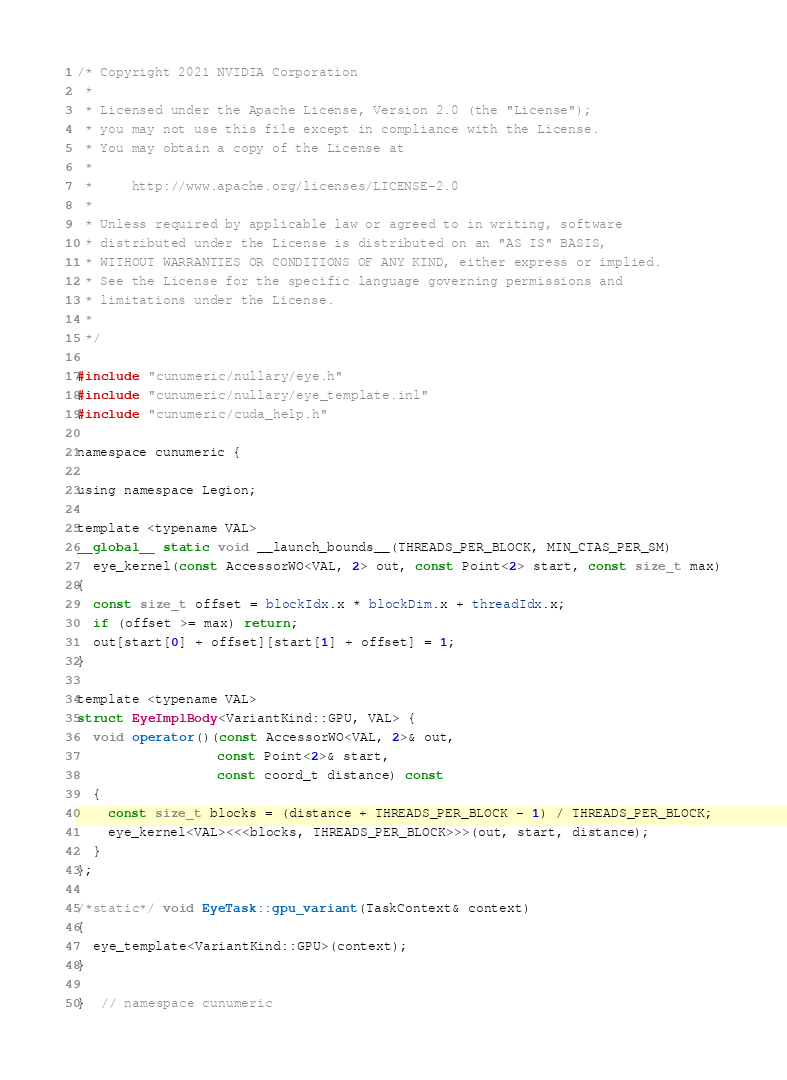<code> <loc_0><loc_0><loc_500><loc_500><_Cuda_>/* Copyright 2021 NVIDIA Corporation
 *
 * Licensed under the Apache License, Version 2.0 (the "License");
 * you may not use this file except in compliance with the License.
 * You may obtain a copy of the License at
 *
 *     http://www.apache.org/licenses/LICENSE-2.0
 *
 * Unless required by applicable law or agreed to in writing, software
 * distributed under the License is distributed on an "AS IS" BASIS,
 * WITHOUT WARRANTIES OR CONDITIONS OF ANY KIND, either express or implied.
 * See the License for the specific language governing permissions and
 * limitations under the License.
 *
 */

#include "cunumeric/nullary/eye.h"
#include "cunumeric/nullary/eye_template.inl"
#include "cunumeric/cuda_help.h"

namespace cunumeric {

using namespace Legion;

template <typename VAL>
__global__ static void __launch_bounds__(THREADS_PER_BLOCK, MIN_CTAS_PER_SM)
  eye_kernel(const AccessorWO<VAL, 2> out, const Point<2> start, const size_t max)
{
  const size_t offset = blockIdx.x * blockDim.x + threadIdx.x;
  if (offset >= max) return;
  out[start[0] + offset][start[1] + offset] = 1;
}

template <typename VAL>
struct EyeImplBody<VariantKind::GPU, VAL> {
  void operator()(const AccessorWO<VAL, 2>& out,
                  const Point<2>& start,
                  const coord_t distance) const
  {
    const size_t blocks = (distance + THREADS_PER_BLOCK - 1) / THREADS_PER_BLOCK;
    eye_kernel<VAL><<<blocks, THREADS_PER_BLOCK>>>(out, start, distance);
  }
};

/*static*/ void EyeTask::gpu_variant(TaskContext& context)
{
  eye_template<VariantKind::GPU>(context);
}

}  // namespace cunumeric
</code> 